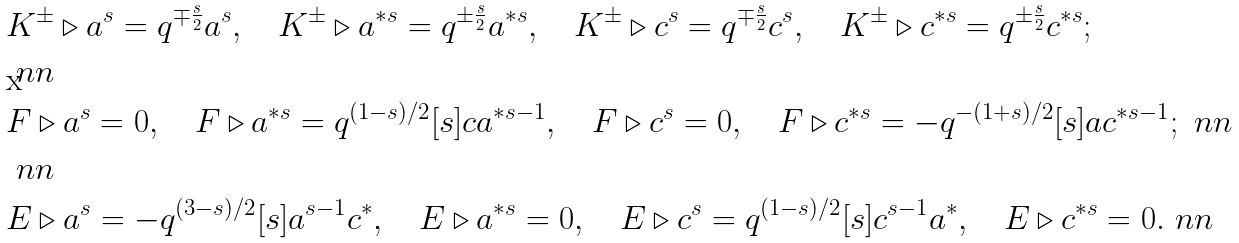<formula> <loc_0><loc_0><loc_500><loc_500>& K ^ { \pm } \triangleright a ^ { s } = q ^ { \mp \frac { s } { 2 } } a ^ { s } , \quad K ^ { \pm } \triangleright a ^ { * s } = q ^ { \pm \frac { s } { 2 } } a ^ { * s } , \quad K ^ { \pm } \triangleright c ^ { s } = q ^ { \mp \frac { s } { 2 } } c ^ { s } , \quad K ^ { \pm } \triangleright c ^ { * s } = q ^ { \pm \frac { s } { 2 } } c ^ { * s } ; \\ & \ n n \\ & F \triangleright a ^ { s } = 0 , \quad F \triangleright a ^ { * s } = q ^ { ( 1 - s ) / 2 } [ s ] c a ^ { * s - 1 } , \quad F \triangleright c ^ { s } = 0 , \quad F \triangleright c ^ { * s } = - q ^ { - ( 1 + s ) / 2 } [ s ] a c ^ { * s - 1 } ; \ n n \\ & \ n n \\ & E \triangleright a ^ { s } = - q ^ { ( 3 - s ) / 2 } [ s ] a ^ { s - 1 } c ^ { * } , \quad E \triangleright a ^ { * s } = 0 , \quad E \triangleright c ^ { s } = q ^ { ( 1 - s ) / 2 } [ s ] c ^ { s - 1 } a ^ { * } , \quad E \triangleright c ^ { * s } = 0 . \ n n</formula> 